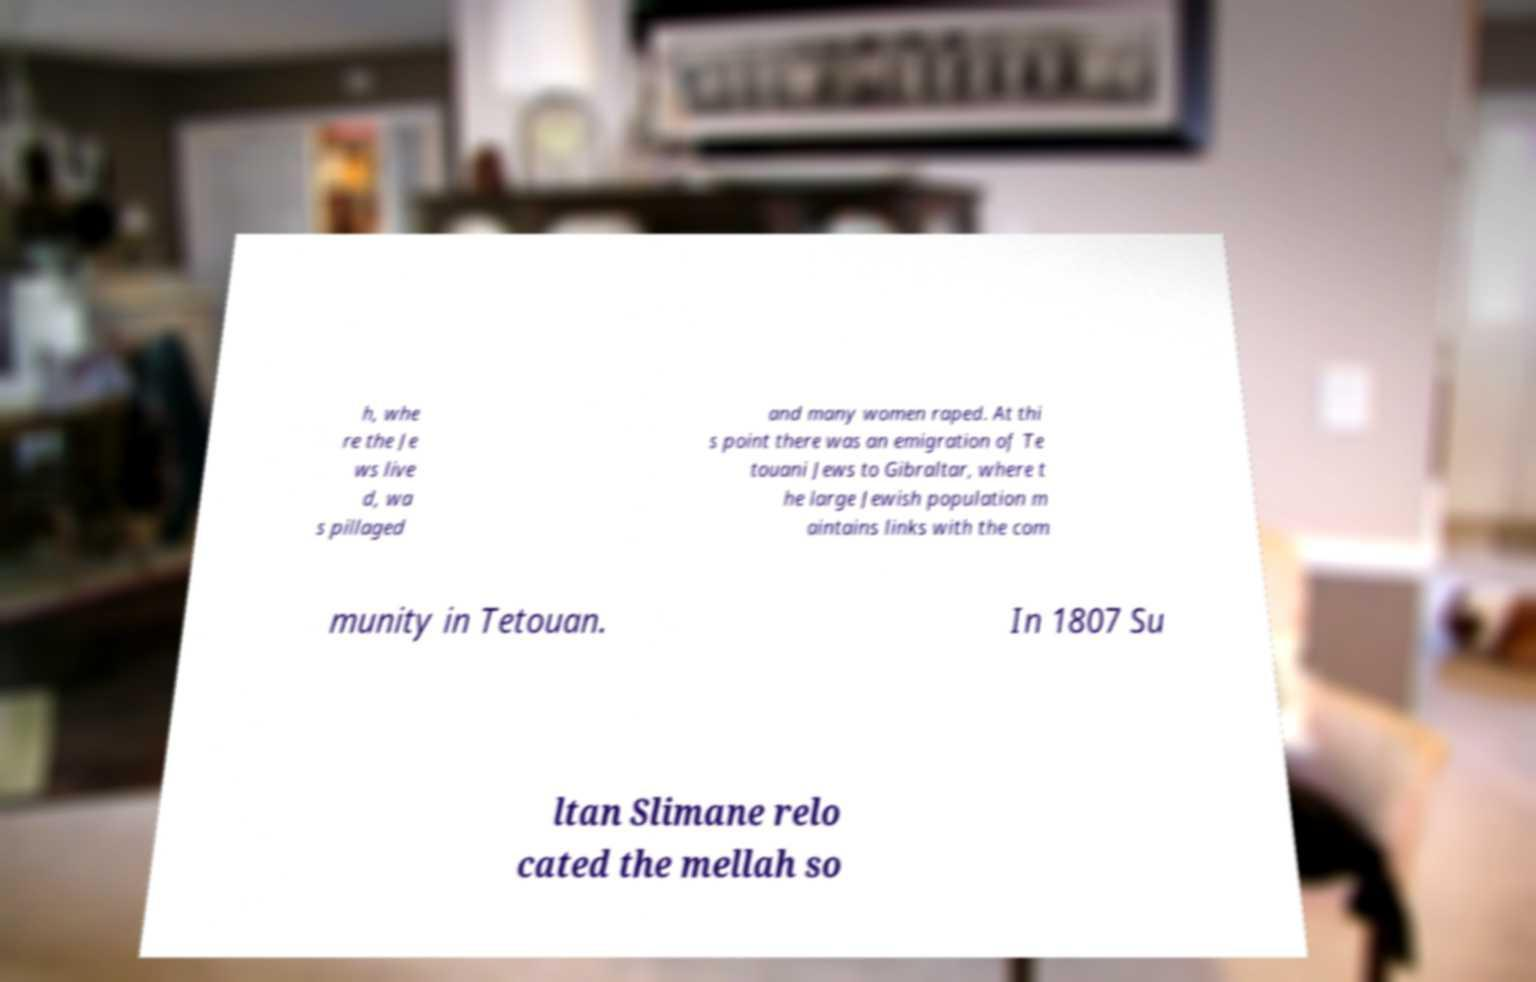Please identify and transcribe the text found in this image. h, whe re the Je ws live d, wa s pillaged and many women raped. At thi s point there was an emigration of Te touani Jews to Gibraltar, where t he large Jewish population m aintains links with the com munity in Tetouan. In 1807 Su ltan Slimane relo cated the mellah so 